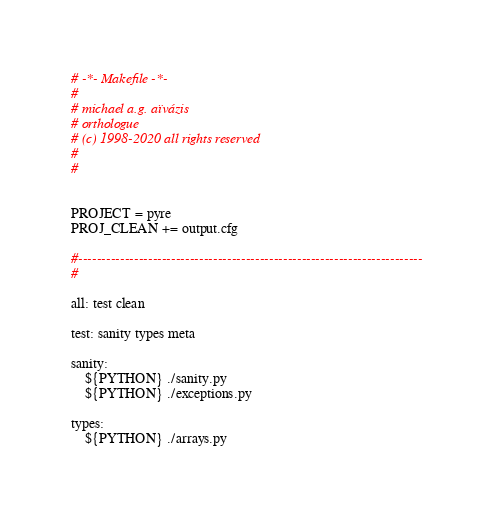Convert code to text. <code><loc_0><loc_0><loc_500><loc_500><_ObjectiveC_># -*- Makefile -*-
#
# michael a.g. aïvázis
# orthologue
# (c) 1998-2020 all rights reserved
#
#


PROJECT = pyre
PROJ_CLEAN += output.cfg

#--------------------------------------------------------------------------
#

all: test clean

test: sanity types meta

sanity:
	${PYTHON} ./sanity.py
	${PYTHON} ./exceptions.py

types:
	${PYTHON} ./arrays.py</code> 